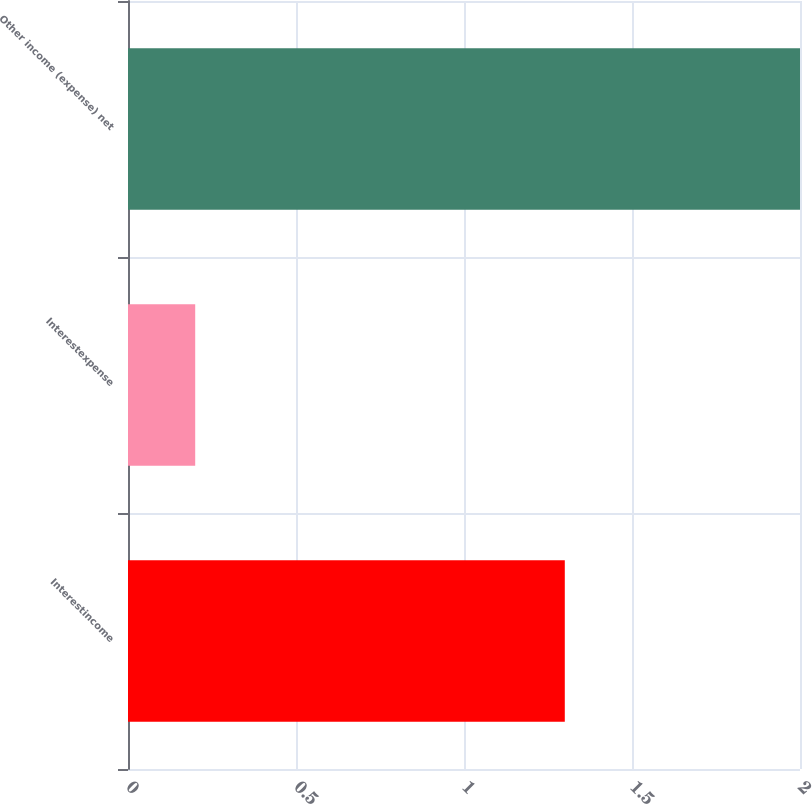Convert chart to OTSL. <chart><loc_0><loc_0><loc_500><loc_500><bar_chart><fcel>Interestincome<fcel>Interestexpense<fcel>Other income (expense) net<nl><fcel>1.3<fcel>0.2<fcel>2<nl></chart> 